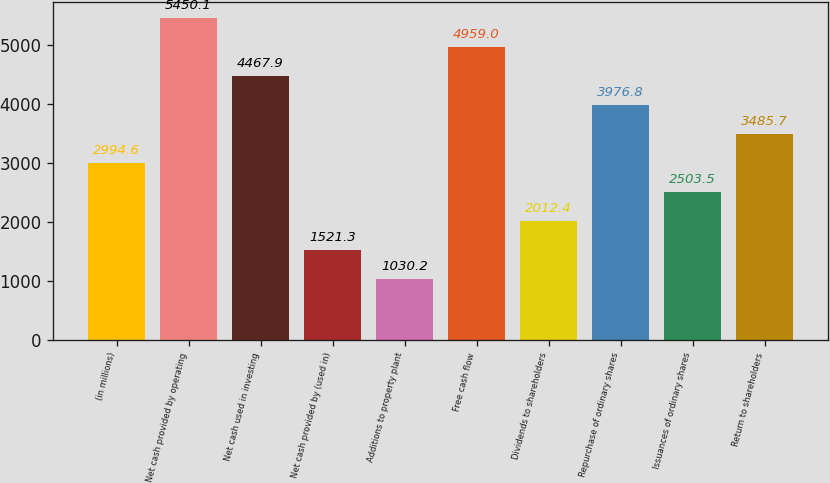<chart> <loc_0><loc_0><loc_500><loc_500><bar_chart><fcel>(in millions)<fcel>Net cash provided by operating<fcel>Net cash used in investing<fcel>Net cash provided by (used in)<fcel>Additions to property plant<fcel>Free cash flow<fcel>Dividends to shareholders<fcel>Repurchase of ordinary shares<fcel>Issuances of ordinary shares<fcel>Return to shareholders<nl><fcel>2994.6<fcel>5450.1<fcel>4467.9<fcel>1521.3<fcel>1030.2<fcel>4959<fcel>2012.4<fcel>3976.8<fcel>2503.5<fcel>3485.7<nl></chart> 